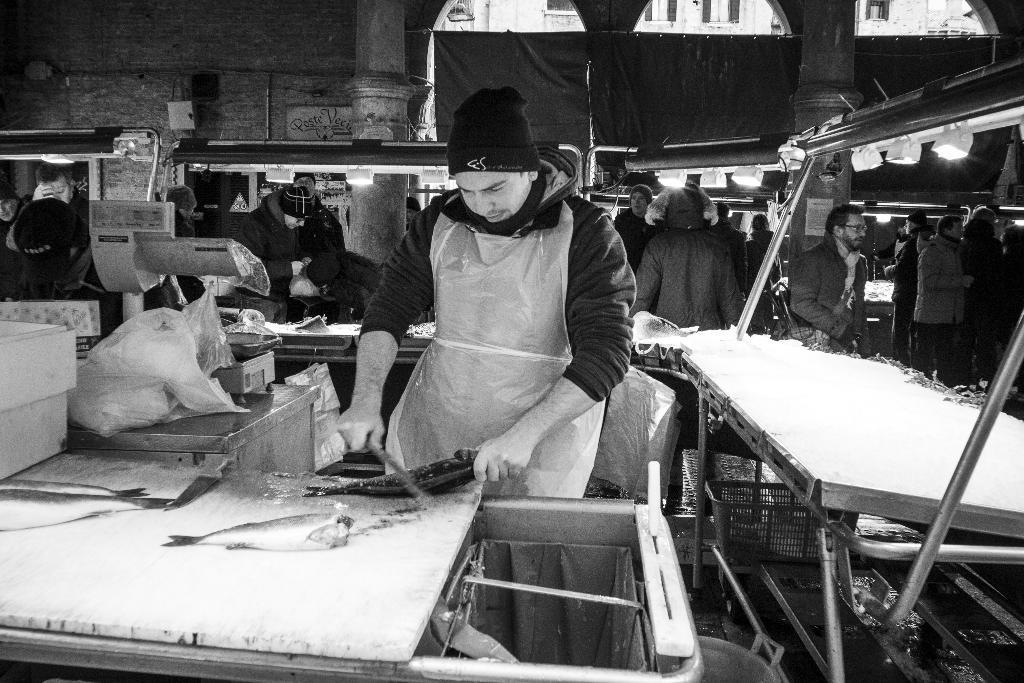What is the man in the image doing? The man is standing and cutting fish. What is the man wearing while performing this task? The man is wearing an apron. Are there any other people in the image? Yes, there are other people in the image. What are the other people doing in the image? The other people are standing in a group behind machines. What type of button is being used to celebrate the birthday in the image? There is no button or birthday celebration present in the image. Where is the office located in the image? There is no office present in the image. 